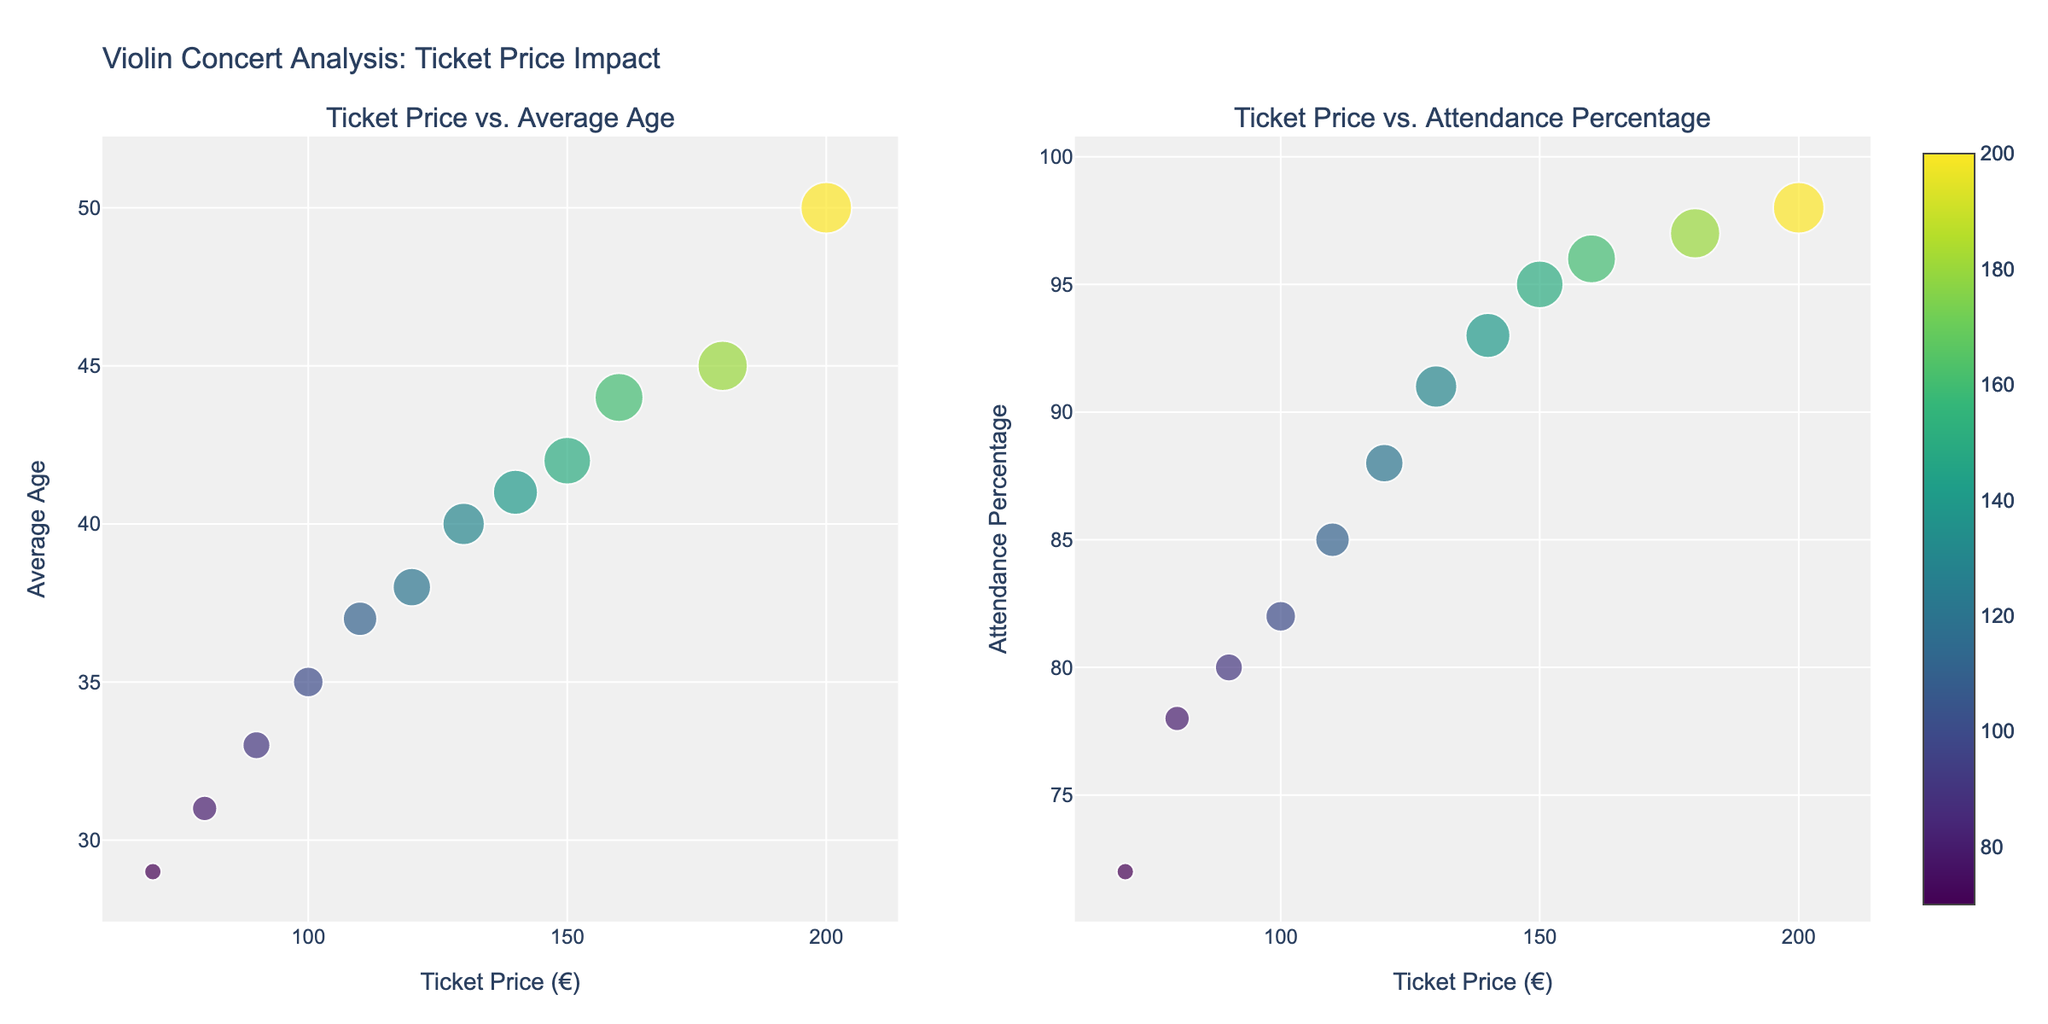What's the title of the figure? The title of the figure is displayed at the top of the plot. It reads "Violin Concert Analysis: Ticket Price Impact".
Answer: Violin Concert Analysis: Ticket Price Impact What are the x-axis labels for both subplots? The x-axis labels for both subplots are written below each scatter plot. They both read "Ticket Price (€)".
Answer: Ticket Price (€) Which concert has the highest ticket price and what is that price? The concert with the highest ticket price is indicated by the data point furthest to the right in both subplots. The highest ticket price is for "Itzhak Perlman at Großer Saal" with a price of €200.
Answer: Itzhak Perlman at Großer Saal, €200 What is the range of average ages for these concerts? The range can be determined by identifying the minimum and maximum values on the y-axis of the left subplot. The lowest average age is 29 and the highest average age is 50.
Answer: 29 to 50 Which concert has the highest attendance percentage and what is that percentage? The concert with the highest attendance percentage is indicated by the data point furthest up in the right subplot. The highest attendance percentage is for "Itzhak Perlman at Großer Saal" with 98%.
Answer: Itzhak Perlman at Großer Saal, 98% How does ticket price correlate with average age? To determine the correlation between ticket price and average age, observe the trend in the left subplot. Higher ticket prices tend to correspond with higher average ages, indicating a positive correlation.
Answer: Positive correlation Which concert has the lowest attendance percentage and what is the ticket price for that concert? The concert with the lowest attendance percentage is the data point furthest down in the right subplot. The lowest attendance percentage is for "Augustin Hadelich at MuTh" with 72%, and the ticket price is €70.
Answer: Augustin Hadelich at MuTh, €70 Is there a concert with a higher attendance percentage than "Hilary Hahn at Musikverein" but a lower average age? If so, which one? Compare the data points for "Hilary Hahn at Musikverein" in both subplots. It has an attendance percentage of 95% and an average age of 42. The concert "Leonidas Kavakos at Mozart-Saal" has a 96% attendance percentage and an average age of 44, which is not lower. "Itzhak Perlman at Großer Saal" has a higher attendance percentage (98%) but higher average age (50). Therefore, no concert fits both criteria.
Answer: No What is the overall trend between ticket price and attendance percentage? To determine the overall trend, observe the general direction of the data points in the right subplot. Higher ticket prices generally correspond with higher attendance percentages, indicating a positive correlation.
Answer: Positive correlation Which concert appears to be an outlier regarding ticket price versus attendance percentage, and why? An outlier in the right subplot is a data point that deviates from the trend. "Anne-Sophie Mutter at Goldener Saal" shows a high ticket price (€180) with a slightly higher than expected attendance percentage (97%), making it a potential outlier in terms of how far it is from other points with similar characteristics.
Answer: Anne-Sophie Mutter at Goldener Saal 